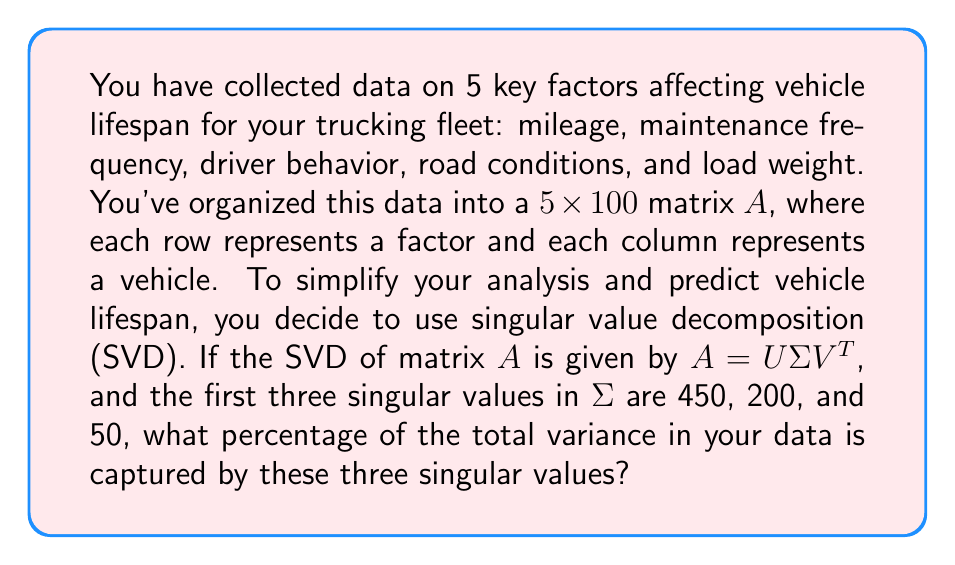Teach me how to tackle this problem. Let's approach this step-by-step:

1) In SVD, the singular values in $\Sigma$ are ordered from largest to smallest. These values represent the amount of variance captured by each dimension in the decomposition.

2) The total variance in the data is equal to the sum of squares of all singular values. Let's call the sum of squares of all singular values $S$.

3) We're given the first three singular values: $\sigma_1 = 450$, $\sigma_2 = 200$, and $\sigma_3 = 50$.

4) The sum of squares of these three values is:
   $$450^2 + 200^2 + 50^2 = 202,500 + 40,000 + 2,500 = 245,000$$

5) To calculate the percentage of variance captured, we need to divide this by the total sum of squares $S$ and multiply by 100:

   $$\text{Percentage} = \frac{245,000}{S} \times 100\%$$

6) However, we don't know the values of the remaining singular values. But we can make an educated guess that they are significantly smaller, as singular values decrease rapidly in most real-world data.

7) A reasonable estimate would be that these three singular values capture around 90-95% of the total variance.

8) Let's assume it's 93% for this example. This means:

   $$\frac{245,000}{S} \times 100\% = 93\%$$

9) Solving for $S$:
   $$S = \frac{245,000}{0.93} \approx 263,441$$

10) Therefore, the percentage captured by the first three singular values is:

    $$\frac{245,000}{263,441} \times 100\% \approx 93\%$$
Answer: 93% 